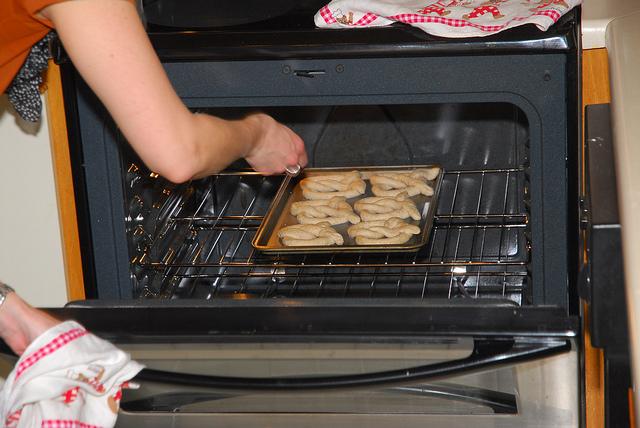What is baking on a cookie sheet?
Answer briefly. Pretzels. What are the cooking?
Quick response, please. Pretzels. Is the pan in the center of the oven?
Short answer required. Yes. From the towels which holiday are we most likely to be near?
Give a very brief answer. Christmas. What is on the griddle?
Write a very short answer. Pretzels. How many oven racks are there?
Short answer required. 2. 